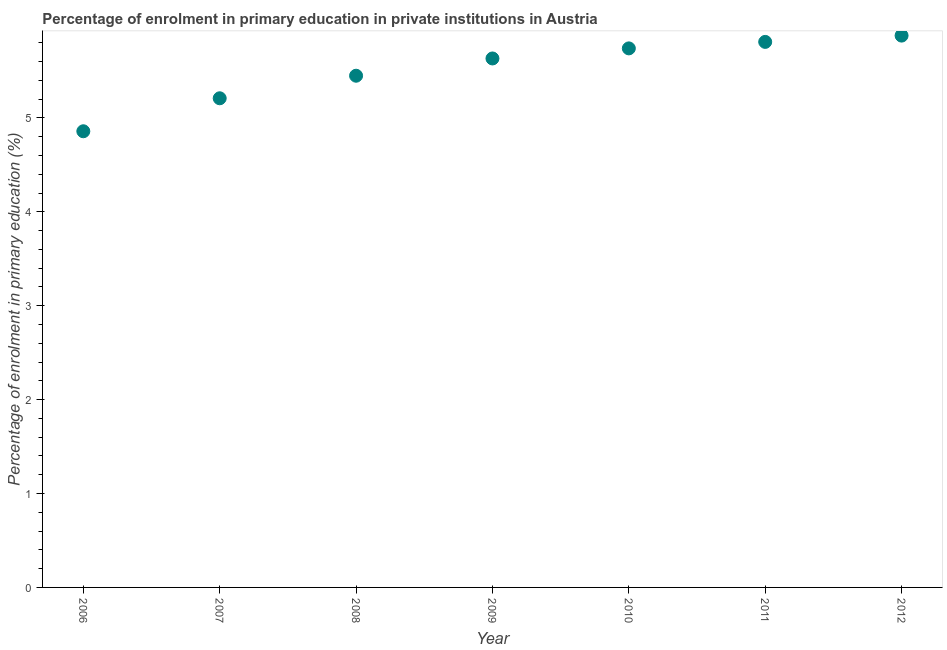What is the enrolment percentage in primary education in 2009?
Your answer should be compact. 5.63. Across all years, what is the maximum enrolment percentage in primary education?
Offer a terse response. 5.88. Across all years, what is the minimum enrolment percentage in primary education?
Keep it short and to the point. 4.86. What is the sum of the enrolment percentage in primary education?
Keep it short and to the point. 38.57. What is the difference between the enrolment percentage in primary education in 2006 and 2008?
Give a very brief answer. -0.59. What is the average enrolment percentage in primary education per year?
Make the answer very short. 5.51. What is the median enrolment percentage in primary education?
Keep it short and to the point. 5.63. In how many years, is the enrolment percentage in primary education greater than 2.2 %?
Your response must be concise. 7. What is the ratio of the enrolment percentage in primary education in 2010 to that in 2012?
Make the answer very short. 0.98. Is the enrolment percentage in primary education in 2007 less than that in 2010?
Offer a terse response. Yes. What is the difference between the highest and the second highest enrolment percentage in primary education?
Offer a very short reply. 0.07. Is the sum of the enrolment percentage in primary education in 2007 and 2010 greater than the maximum enrolment percentage in primary education across all years?
Keep it short and to the point. Yes. What is the difference between the highest and the lowest enrolment percentage in primary education?
Offer a terse response. 1.02. In how many years, is the enrolment percentage in primary education greater than the average enrolment percentage in primary education taken over all years?
Your answer should be very brief. 4. Does the enrolment percentage in primary education monotonically increase over the years?
Give a very brief answer. Yes. How many dotlines are there?
Ensure brevity in your answer.  1. How many years are there in the graph?
Your response must be concise. 7. What is the difference between two consecutive major ticks on the Y-axis?
Keep it short and to the point. 1. Are the values on the major ticks of Y-axis written in scientific E-notation?
Offer a very short reply. No. Does the graph contain any zero values?
Provide a short and direct response. No. What is the title of the graph?
Give a very brief answer. Percentage of enrolment in primary education in private institutions in Austria. What is the label or title of the Y-axis?
Provide a succinct answer. Percentage of enrolment in primary education (%). What is the Percentage of enrolment in primary education (%) in 2006?
Provide a short and direct response. 4.86. What is the Percentage of enrolment in primary education (%) in 2007?
Your response must be concise. 5.21. What is the Percentage of enrolment in primary education (%) in 2008?
Your answer should be compact. 5.45. What is the Percentage of enrolment in primary education (%) in 2009?
Your answer should be very brief. 5.63. What is the Percentage of enrolment in primary education (%) in 2010?
Ensure brevity in your answer.  5.74. What is the Percentage of enrolment in primary education (%) in 2011?
Provide a short and direct response. 5.81. What is the Percentage of enrolment in primary education (%) in 2012?
Give a very brief answer. 5.88. What is the difference between the Percentage of enrolment in primary education (%) in 2006 and 2007?
Keep it short and to the point. -0.35. What is the difference between the Percentage of enrolment in primary education (%) in 2006 and 2008?
Offer a very short reply. -0.59. What is the difference between the Percentage of enrolment in primary education (%) in 2006 and 2009?
Your response must be concise. -0.78. What is the difference between the Percentage of enrolment in primary education (%) in 2006 and 2010?
Make the answer very short. -0.88. What is the difference between the Percentage of enrolment in primary education (%) in 2006 and 2011?
Make the answer very short. -0.95. What is the difference between the Percentage of enrolment in primary education (%) in 2006 and 2012?
Make the answer very short. -1.02. What is the difference between the Percentage of enrolment in primary education (%) in 2007 and 2008?
Make the answer very short. -0.24. What is the difference between the Percentage of enrolment in primary education (%) in 2007 and 2009?
Offer a terse response. -0.42. What is the difference between the Percentage of enrolment in primary education (%) in 2007 and 2010?
Ensure brevity in your answer.  -0.53. What is the difference between the Percentage of enrolment in primary education (%) in 2007 and 2011?
Provide a short and direct response. -0.6. What is the difference between the Percentage of enrolment in primary education (%) in 2007 and 2012?
Keep it short and to the point. -0.67. What is the difference between the Percentage of enrolment in primary education (%) in 2008 and 2009?
Your answer should be very brief. -0.18. What is the difference between the Percentage of enrolment in primary education (%) in 2008 and 2010?
Your answer should be compact. -0.29. What is the difference between the Percentage of enrolment in primary education (%) in 2008 and 2011?
Keep it short and to the point. -0.36. What is the difference between the Percentage of enrolment in primary education (%) in 2008 and 2012?
Give a very brief answer. -0.43. What is the difference between the Percentage of enrolment in primary education (%) in 2009 and 2010?
Your answer should be compact. -0.11. What is the difference between the Percentage of enrolment in primary education (%) in 2009 and 2011?
Make the answer very short. -0.18. What is the difference between the Percentage of enrolment in primary education (%) in 2009 and 2012?
Provide a short and direct response. -0.24. What is the difference between the Percentage of enrolment in primary education (%) in 2010 and 2011?
Your response must be concise. -0.07. What is the difference between the Percentage of enrolment in primary education (%) in 2010 and 2012?
Offer a very short reply. -0.14. What is the difference between the Percentage of enrolment in primary education (%) in 2011 and 2012?
Your answer should be very brief. -0.07. What is the ratio of the Percentage of enrolment in primary education (%) in 2006 to that in 2007?
Provide a short and direct response. 0.93. What is the ratio of the Percentage of enrolment in primary education (%) in 2006 to that in 2008?
Ensure brevity in your answer.  0.89. What is the ratio of the Percentage of enrolment in primary education (%) in 2006 to that in 2009?
Provide a short and direct response. 0.86. What is the ratio of the Percentage of enrolment in primary education (%) in 2006 to that in 2010?
Offer a terse response. 0.85. What is the ratio of the Percentage of enrolment in primary education (%) in 2006 to that in 2011?
Make the answer very short. 0.84. What is the ratio of the Percentage of enrolment in primary education (%) in 2006 to that in 2012?
Your response must be concise. 0.83. What is the ratio of the Percentage of enrolment in primary education (%) in 2007 to that in 2008?
Your response must be concise. 0.96. What is the ratio of the Percentage of enrolment in primary education (%) in 2007 to that in 2009?
Make the answer very short. 0.93. What is the ratio of the Percentage of enrolment in primary education (%) in 2007 to that in 2010?
Your answer should be compact. 0.91. What is the ratio of the Percentage of enrolment in primary education (%) in 2007 to that in 2011?
Provide a short and direct response. 0.9. What is the ratio of the Percentage of enrolment in primary education (%) in 2007 to that in 2012?
Ensure brevity in your answer.  0.89. What is the ratio of the Percentage of enrolment in primary education (%) in 2008 to that in 2009?
Offer a terse response. 0.97. What is the ratio of the Percentage of enrolment in primary education (%) in 2008 to that in 2010?
Your answer should be compact. 0.95. What is the ratio of the Percentage of enrolment in primary education (%) in 2008 to that in 2011?
Give a very brief answer. 0.94. What is the ratio of the Percentage of enrolment in primary education (%) in 2008 to that in 2012?
Provide a succinct answer. 0.93. What is the ratio of the Percentage of enrolment in primary education (%) in 2009 to that in 2012?
Offer a very short reply. 0.96. 